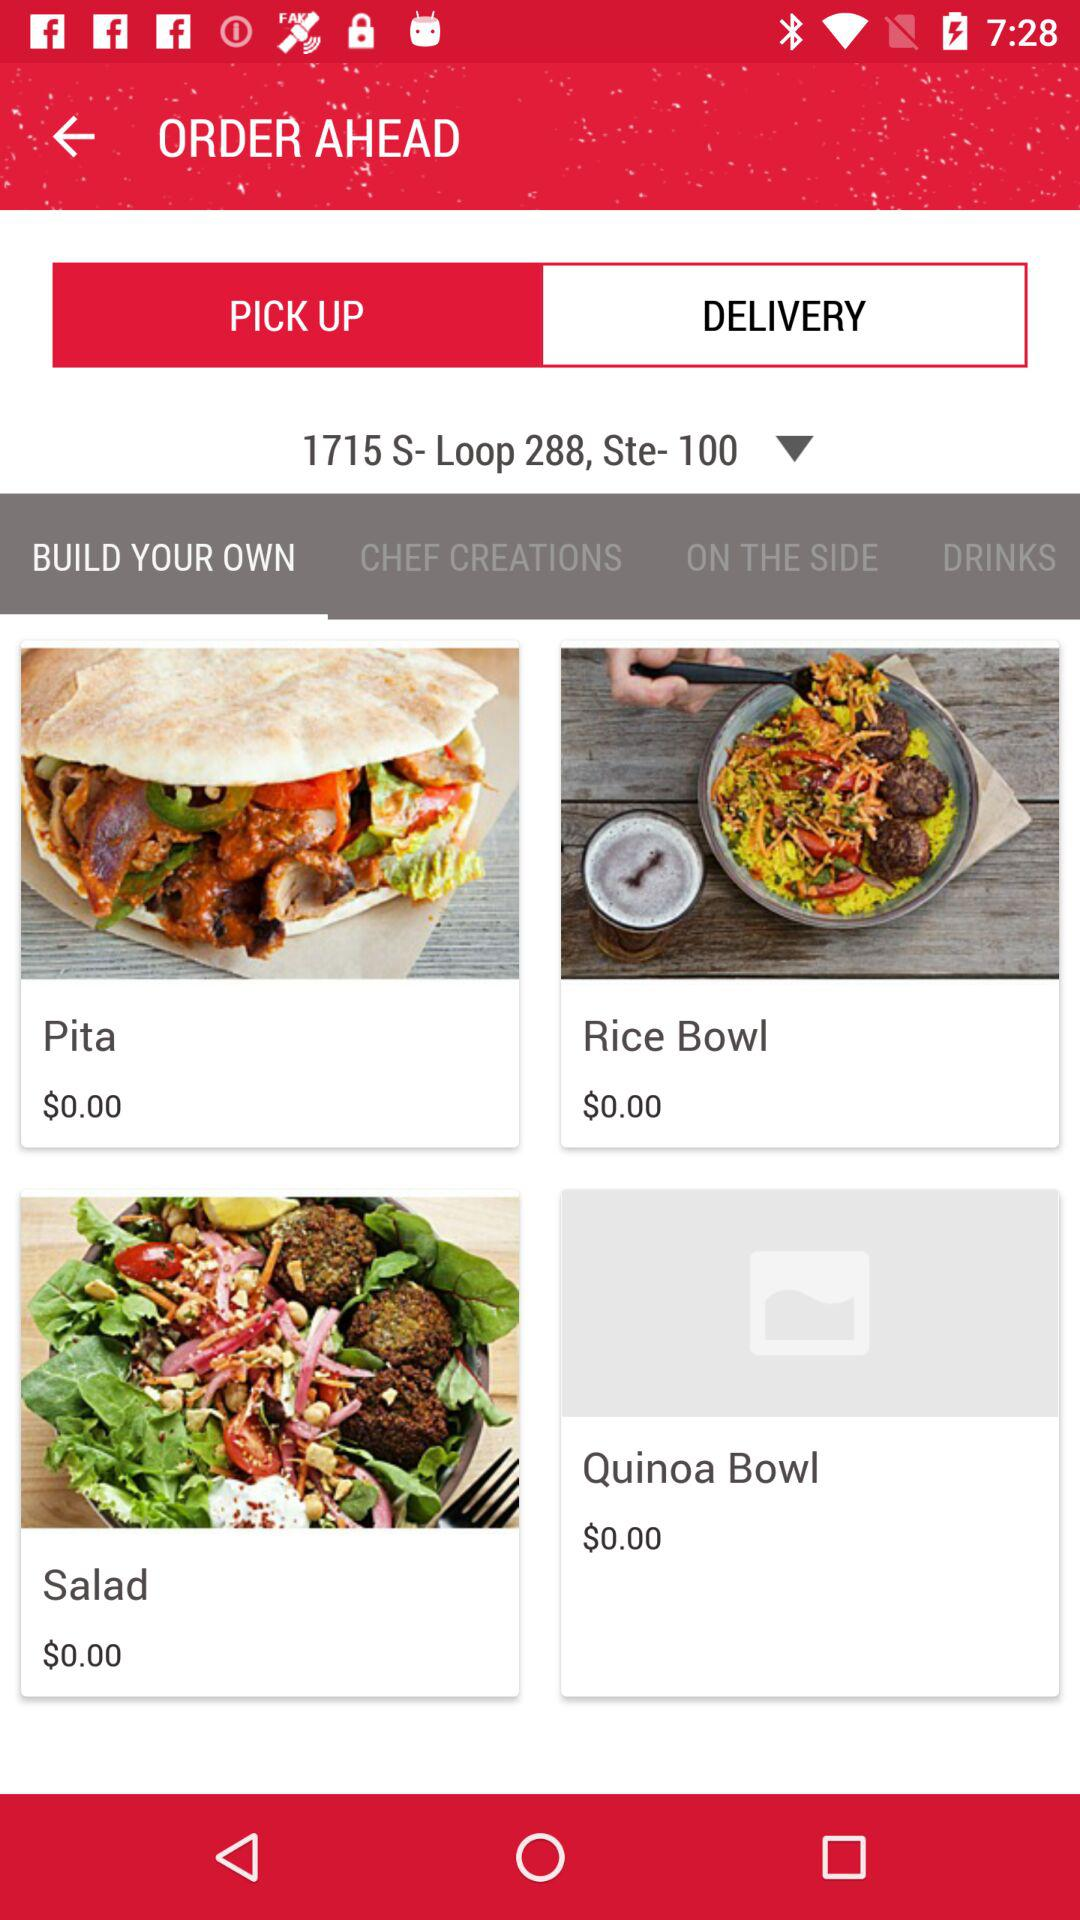Which option is selected "PICK UP" or "DELIVERY"? The selected option is "PICK UP". 